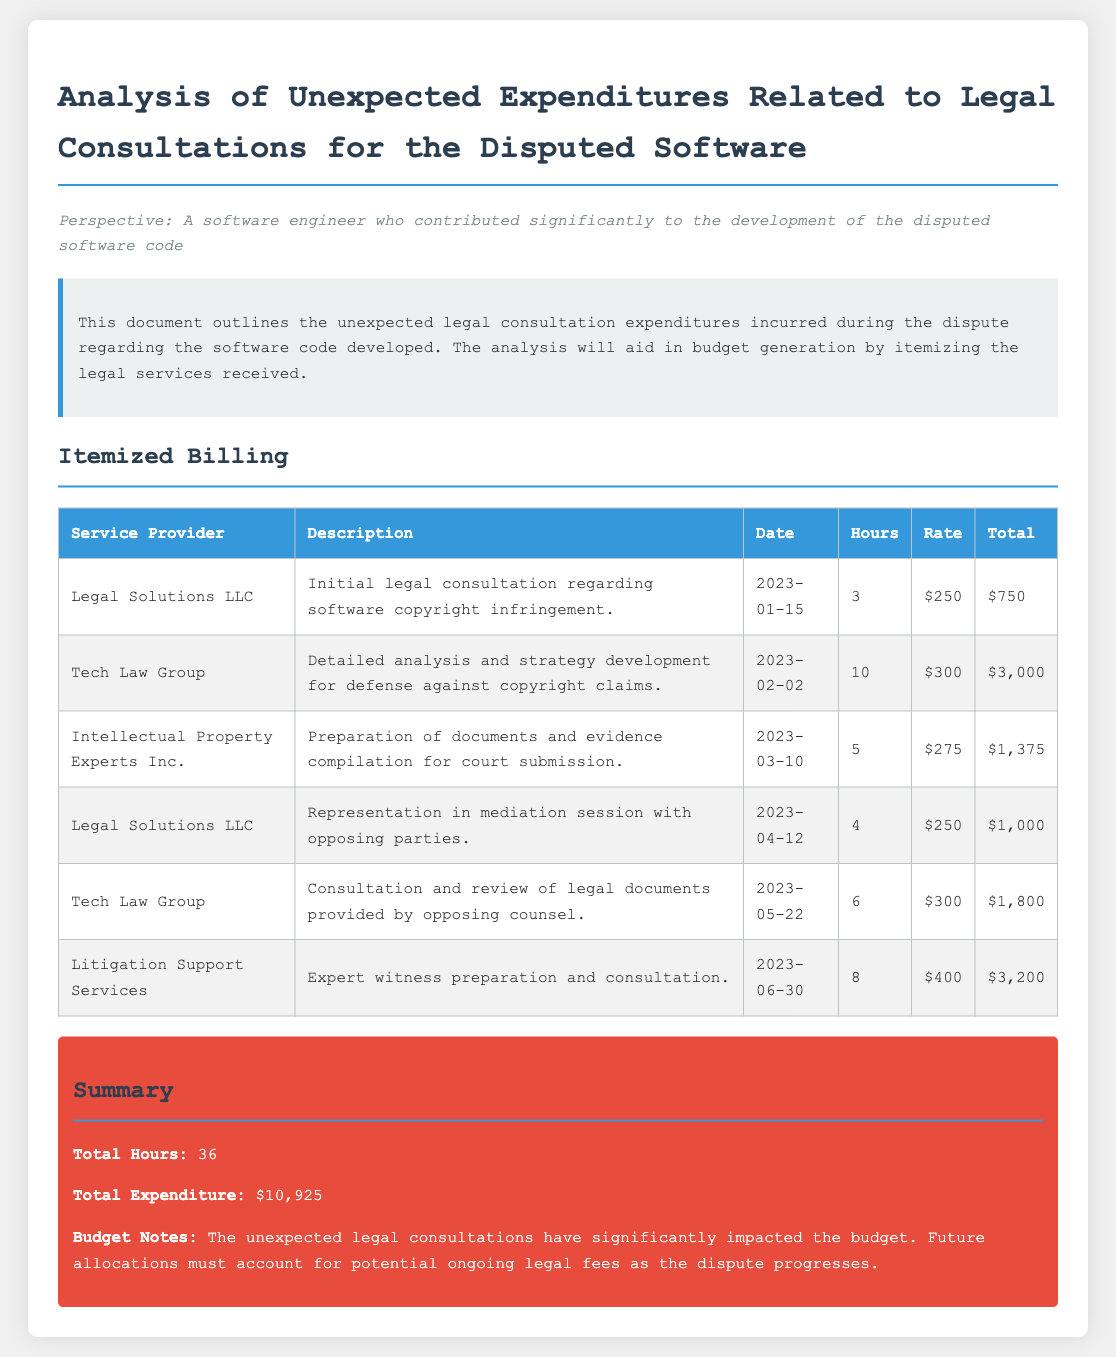What is the total expenditure for legal consultations? The total expenditure is provided in the summary section, which adds up all the costs from itemized billing.
Answer: $10,925 How many hours were spent on legal consultations? The total hours are summarized at the end of the document, indicating the accumulated time devoted to legal services.
Answer: 36 What is the date of the initial legal consultation? The date for the initial legal consultation is listed in the itemized billing section for the first service provider.
Answer: 2023-01-15 Which service provider handled the expert witness preparation? The document identifies the specific service provider responsible for expert witness preparation in the itemized billing section.
Answer: Litigation Support Services What was the rate charged by Tech Law Group? The rate charged by Tech Law Group is specified in the itemized billing for the services they provided.
Answer: $300 Which legal service incurred the highest total expenditure? The total amounts for each service are noted in the itemized billing, and the maximum is the highest among them.
Answer: $3,200 What service was provided on 2023-04-12? The date mentioned corresponds to a specific legal service listed in the itemized section of the document.
Answer: Representation in mediation session How many hours were devoted to document preparation by Intellectual Property Experts Inc.? The itemized billing details the hours assigned to the service provided by this firm, helping identify the specific time allocation.
Answer: 5 What is the acknowledgment in the budget notes section? The budget notes summarize the implications of unexpected legal fees and emphasize considerations for future budgeting.
Answer: Ongoing legal fees 